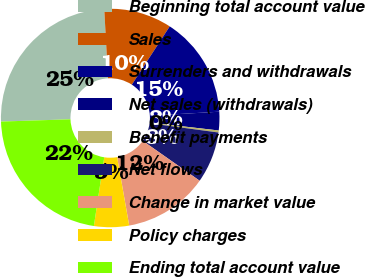<chart> <loc_0><loc_0><loc_500><loc_500><pie_chart><fcel>Beginning total account value<fcel>Sales<fcel>Surrenders and withdrawals<fcel>Net sales (withdrawals)<fcel>Benefit payments<fcel>Net flows<fcel>Change in market value<fcel>Policy charges<fcel>Ending total account value<nl><fcel>24.65%<fcel>10.04%<fcel>14.91%<fcel>2.74%<fcel>0.3%<fcel>7.61%<fcel>12.48%<fcel>5.17%<fcel>22.09%<nl></chart> 